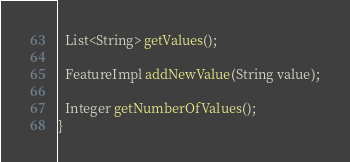<code> <loc_0><loc_0><loc_500><loc_500><_Java_>
  List<String> getValues();

  FeatureImpl addNewValue(String value);

  Integer getNumberOfValues();
}
</code> 